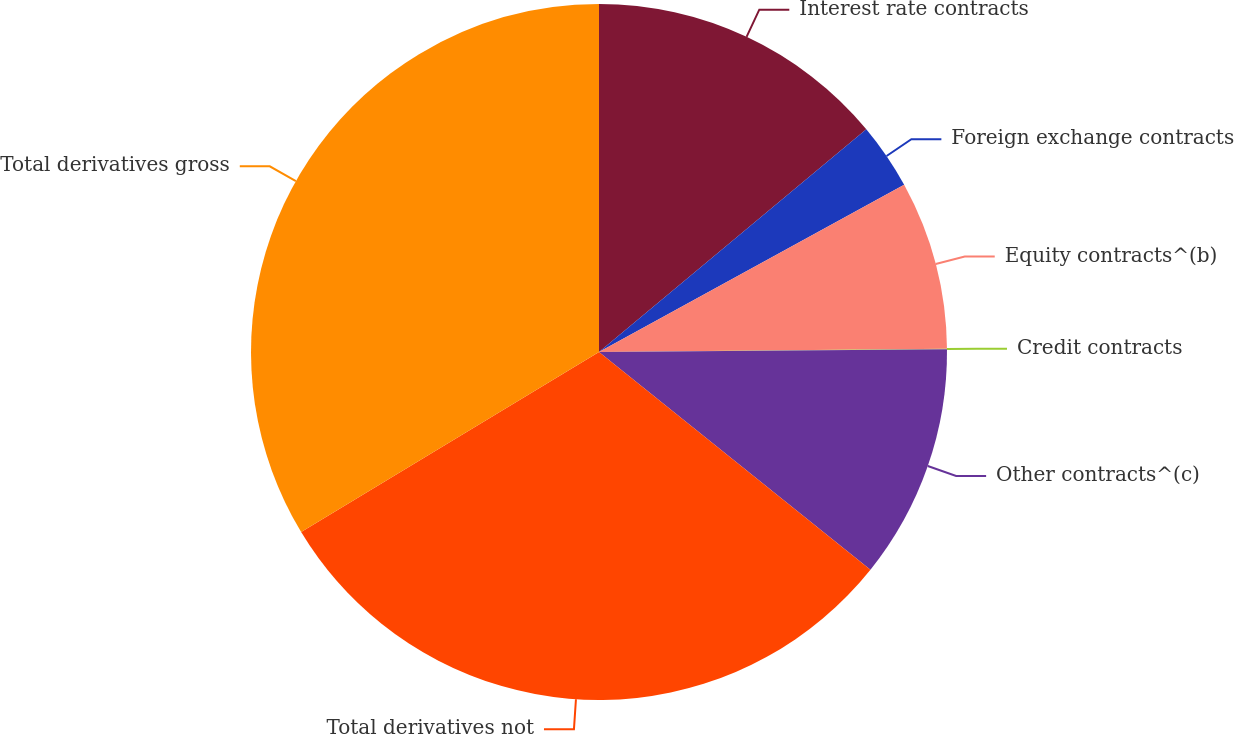<chart> <loc_0><loc_0><loc_500><loc_500><pie_chart><fcel>Interest rate contracts<fcel>Foreign exchange contracts<fcel>Equity contracts^(b)<fcel>Credit contracts<fcel>Other contracts^(c)<fcel>Total derivatives not<fcel>Total derivatives gross<nl><fcel>13.94%<fcel>3.08%<fcel>7.83%<fcel>0.02%<fcel>10.89%<fcel>30.59%<fcel>33.65%<nl></chart> 